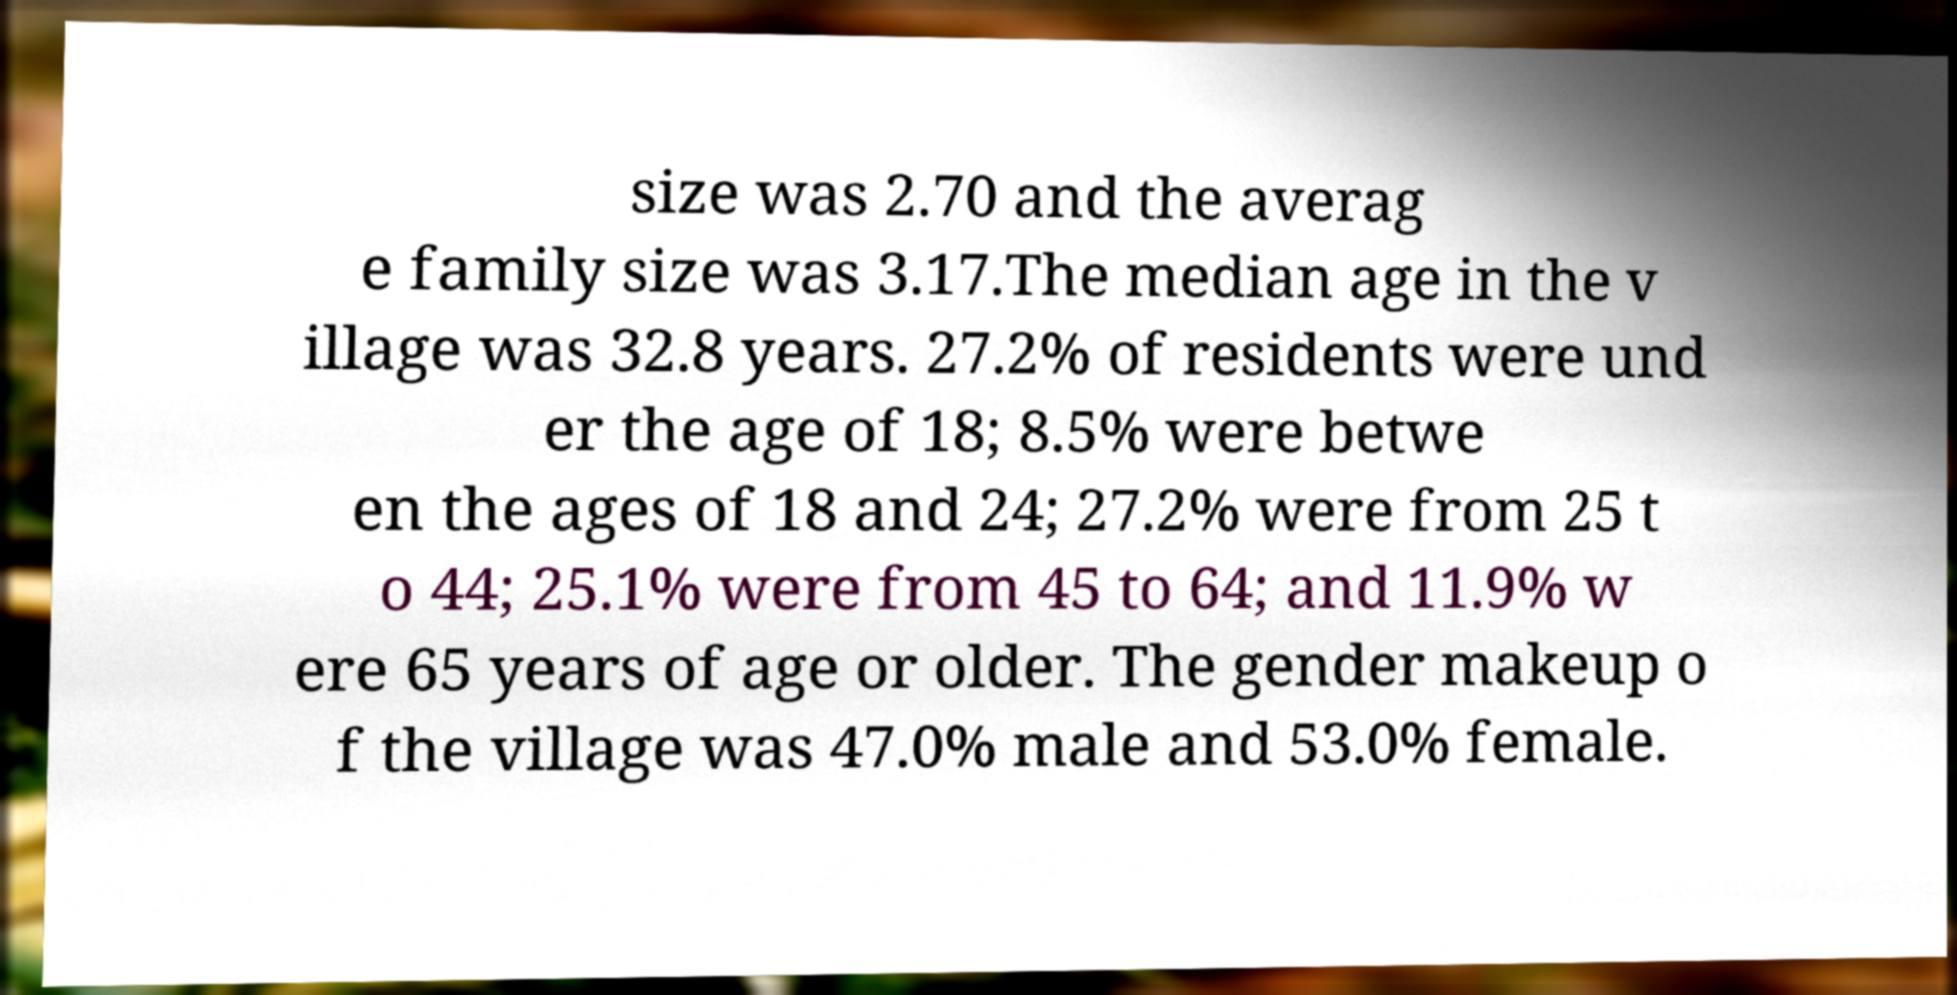I need the written content from this picture converted into text. Can you do that? size was 2.70 and the averag e family size was 3.17.The median age in the v illage was 32.8 years. 27.2% of residents were und er the age of 18; 8.5% were betwe en the ages of 18 and 24; 27.2% were from 25 t o 44; 25.1% were from 45 to 64; and 11.9% w ere 65 years of age or older. The gender makeup o f the village was 47.0% male and 53.0% female. 